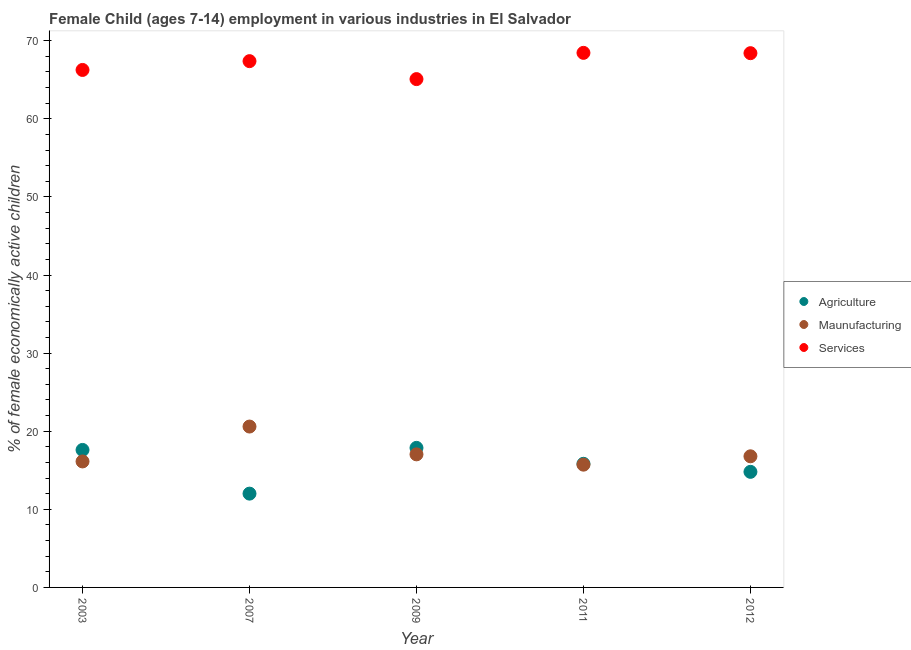Is the number of dotlines equal to the number of legend labels?
Offer a very short reply. Yes. What is the percentage of economically active children in manufacturing in 2009?
Your answer should be very brief. 17.04. Across all years, what is the maximum percentage of economically active children in agriculture?
Offer a terse response. 17.87. Across all years, what is the minimum percentage of economically active children in agriculture?
Provide a short and direct response. 12.01. What is the total percentage of economically active children in services in the graph?
Provide a succinct answer. 335.6. What is the difference between the percentage of economically active children in agriculture in 2003 and that in 2007?
Provide a short and direct response. 5.6. What is the difference between the percentage of economically active children in services in 2012 and the percentage of economically active children in manufacturing in 2009?
Offer a very short reply. 51.37. What is the average percentage of economically active children in agriculture per year?
Provide a succinct answer. 15.62. In the year 2009, what is the difference between the percentage of economically active children in services and percentage of economically active children in manufacturing?
Keep it short and to the point. 48.05. What is the ratio of the percentage of economically active children in manufacturing in 2003 to that in 2007?
Keep it short and to the point. 0.78. Is the difference between the percentage of economically active children in services in 2009 and 2011 greater than the difference between the percentage of economically active children in manufacturing in 2009 and 2011?
Keep it short and to the point. No. What is the difference between the highest and the second highest percentage of economically active children in services?
Provide a short and direct response. 0.04. What is the difference between the highest and the lowest percentage of economically active children in services?
Ensure brevity in your answer.  3.36. Is the sum of the percentage of economically active children in manufacturing in 2009 and 2011 greater than the maximum percentage of economically active children in services across all years?
Make the answer very short. No. Is it the case that in every year, the sum of the percentage of economically active children in agriculture and percentage of economically active children in manufacturing is greater than the percentage of economically active children in services?
Offer a very short reply. No. Is the percentage of economically active children in manufacturing strictly greater than the percentage of economically active children in services over the years?
Provide a succinct answer. No. Are the values on the major ticks of Y-axis written in scientific E-notation?
Your answer should be very brief. No. Does the graph contain grids?
Give a very brief answer. No. Where does the legend appear in the graph?
Make the answer very short. Center right. How are the legend labels stacked?
Your answer should be very brief. Vertical. What is the title of the graph?
Provide a succinct answer. Female Child (ages 7-14) employment in various industries in El Salvador. What is the label or title of the Y-axis?
Offer a terse response. % of female economically active children. What is the % of female economically active children in Agriculture in 2003?
Make the answer very short. 17.61. What is the % of female economically active children in Maunufacturing in 2003?
Give a very brief answer. 16.13. What is the % of female economically active children in Services in 2003?
Provide a succinct answer. 66.26. What is the % of female economically active children of Agriculture in 2007?
Your response must be concise. 12.01. What is the % of female economically active children in Maunufacturing in 2007?
Provide a short and direct response. 20.6. What is the % of female economically active children in Services in 2007?
Keep it short and to the point. 67.39. What is the % of female economically active children of Agriculture in 2009?
Make the answer very short. 17.87. What is the % of female economically active children of Maunufacturing in 2009?
Provide a succinct answer. 17.04. What is the % of female economically active children of Services in 2009?
Offer a very short reply. 65.09. What is the % of female economically active children in Agriculture in 2011?
Ensure brevity in your answer.  15.83. What is the % of female economically active children in Maunufacturing in 2011?
Give a very brief answer. 15.72. What is the % of female economically active children in Services in 2011?
Provide a succinct answer. 68.45. What is the % of female economically active children in Maunufacturing in 2012?
Keep it short and to the point. 16.79. What is the % of female economically active children in Services in 2012?
Offer a terse response. 68.41. Across all years, what is the maximum % of female economically active children in Agriculture?
Give a very brief answer. 17.87. Across all years, what is the maximum % of female economically active children of Maunufacturing?
Your answer should be compact. 20.6. Across all years, what is the maximum % of female economically active children in Services?
Your answer should be compact. 68.45. Across all years, what is the minimum % of female economically active children in Agriculture?
Provide a short and direct response. 12.01. Across all years, what is the minimum % of female economically active children in Maunufacturing?
Provide a short and direct response. 15.72. Across all years, what is the minimum % of female economically active children of Services?
Provide a succinct answer. 65.09. What is the total % of female economically active children of Agriculture in the graph?
Provide a succinct answer. 78.12. What is the total % of female economically active children of Maunufacturing in the graph?
Make the answer very short. 86.28. What is the total % of female economically active children of Services in the graph?
Your answer should be compact. 335.6. What is the difference between the % of female economically active children of Agriculture in 2003 and that in 2007?
Your response must be concise. 5.6. What is the difference between the % of female economically active children of Maunufacturing in 2003 and that in 2007?
Give a very brief answer. -4.47. What is the difference between the % of female economically active children of Services in 2003 and that in 2007?
Offer a very short reply. -1.13. What is the difference between the % of female economically active children in Agriculture in 2003 and that in 2009?
Your answer should be compact. -0.26. What is the difference between the % of female economically active children of Maunufacturing in 2003 and that in 2009?
Keep it short and to the point. -0.91. What is the difference between the % of female economically active children in Services in 2003 and that in 2009?
Offer a very short reply. 1.17. What is the difference between the % of female economically active children in Agriculture in 2003 and that in 2011?
Provide a succinct answer. 1.78. What is the difference between the % of female economically active children of Maunufacturing in 2003 and that in 2011?
Ensure brevity in your answer.  0.41. What is the difference between the % of female economically active children of Services in 2003 and that in 2011?
Offer a very short reply. -2.19. What is the difference between the % of female economically active children of Agriculture in 2003 and that in 2012?
Keep it short and to the point. 2.81. What is the difference between the % of female economically active children in Maunufacturing in 2003 and that in 2012?
Offer a very short reply. -0.66. What is the difference between the % of female economically active children in Services in 2003 and that in 2012?
Your response must be concise. -2.15. What is the difference between the % of female economically active children in Agriculture in 2007 and that in 2009?
Give a very brief answer. -5.86. What is the difference between the % of female economically active children in Maunufacturing in 2007 and that in 2009?
Provide a succinct answer. 3.56. What is the difference between the % of female economically active children of Services in 2007 and that in 2009?
Your answer should be compact. 2.3. What is the difference between the % of female economically active children of Agriculture in 2007 and that in 2011?
Offer a very short reply. -3.82. What is the difference between the % of female economically active children of Maunufacturing in 2007 and that in 2011?
Your response must be concise. 4.88. What is the difference between the % of female economically active children of Services in 2007 and that in 2011?
Offer a very short reply. -1.06. What is the difference between the % of female economically active children in Agriculture in 2007 and that in 2012?
Provide a short and direct response. -2.79. What is the difference between the % of female economically active children in Maunufacturing in 2007 and that in 2012?
Make the answer very short. 3.81. What is the difference between the % of female economically active children of Services in 2007 and that in 2012?
Provide a succinct answer. -1.02. What is the difference between the % of female economically active children in Agriculture in 2009 and that in 2011?
Provide a succinct answer. 2.04. What is the difference between the % of female economically active children of Maunufacturing in 2009 and that in 2011?
Your response must be concise. 1.32. What is the difference between the % of female economically active children in Services in 2009 and that in 2011?
Your answer should be compact. -3.36. What is the difference between the % of female economically active children in Agriculture in 2009 and that in 2012?
Offer a very short reply. 3.07. What is the difference between the % of female economically active children in Services in 2009 and that in 2012?
Your answer should be very brief. -3.32. What is the difference between the % of female economically active children in Agriculture in 2011 and that in 2012?
Keep it short and to the point. 1.03. What is the difference between the % of female economically active children in Maunufacturing in 2011 and that in 2012?
Offer a terse response. -1.07. What is the difference between the % of female economically active children of Agriculture in 2003 and the % of female economically active children of Maunufacturing in 2007?
Provide a short and direct response. -2.99. What is the difference between the % of female economically active children of Agriculture in 2003 and the % of female economically active children of Services in 2007?
Offer a very short reply. -49.78. What is the difference between the % of female economically active children of Maunufacturing in 2003 and the % of female economically active children of Services in 2007?
Your response must be concise. -51.26. What is the difference between the % of female economically active children of Agriculture in 2003 and the % of female economically active children of Maunufacturing in 2009?
Your response must be concise. 0.57. What is the difference between the % of female economically active children of Agriculture in 2003 and the % of female economically active children of Services in 2009?
Make the answer very short. -47.48. What is the difference between the % of female economically active children of Maunufacturing in 2003 and the % of female economically active children of Services in 2009?
Provide a short and direct response. -48.96. What is the difference between the % of female economically active children in Agriculture in 2003 and the % of female economically active children in Maunufacturing in 2011?
Your response must be concise. 1.89. What is the difference between the % of female economically active children in Agriculture in 2003 and the % of female economically active children in Services in 2011?
Offer a very short reply. -50.84. What is the difference between the % of female economically active children in Maunufacturing in 2003 and the % of female economically active children in Services in 2011?
Give a very brief answer. -52.32. What is the difference between the % of female economically active children in Agriculture in 2003 and the % of female economically active children in Maunufacturing in 2012?
Give a very brief answer. 0.82. What is the difference between the % of female economically active children of Agriculture in 2003 and the % of female economically active children of Services in 2012?
Your answer should be very brief. -50.8. What is the difference between the % of female economically active children in Maunufacturing in 2003 and the % of female economically active children in Services in 2012?
Give a very brief answer. -52.28. What is the difference between the % of female economically active children in Agriculture in 2007 and the % of female economically active children in Maunufacturing in 2009?
Give a very brief answer. -5.03. What is the difference between the % of female economically active children in Agriculture in 2007 and the % of female economically active children in Services in 2009?
Your response must be concise. -53.08. What is the difference between the % of female economically active children in Maunufacturing in 2007 and the % of female economically active children in Services in 2009?
Make the answer very short. -44.49. What is the difference between the % of female economically active children in Agriculture in 2007 and the % of female economically active children in Maunufacturing in 2011?
Ensure brevity in your answer.  -3.71. What is the difference between the % of female economically active children of Agriculture in 2007 and the % of female economically active children of Services in 2011?
Offer a very short reply. -56.44. What is the difference between the % of female economically active children in Maunufacturing in 2007 and the % of female economically active children in Services in 2011?
Ensure brevity in your answer.  -47.85. What is the difference between the % of female economically active children in Agriculture in 2007 and the % of female economically active children in Maunufacturing in 2012?
Ensure brevity in your answer.  -4.78. What is the difference between the % of female economically active children of Agriculture in 2007 and the % of female economically active children of Services in 2012?
Keep it short and to the point. -56.4. What is the difference between the % of female economically active children in Maunufacturing in 2007 and the % of female economically active children in Services in 2012?
Provide a succinct answer. -47.81. What is the difference between the % of female economically active children of Agriculture in 2009 and the % of female economically active children of Maunufacturing in 2011?
Provide a succinct answer. 2.15. What is the difference between the % of female economically active children in Agriculture in 2009 and the % of female economically active children in Services in 2011?
Your response must be concise. -50.58. What is the difference between the % of female economically active children of Maunufacturing in 2009 and the % of female economically active children of Services in 2011?
Keep it short and to the point. -51.41. What is the difference between the % of female economically active children in Agriculture in 2009 and the % of female economically active children in Maunufacturing in 2012?
Your answer should be compact. 1.08. What is the difference between the % of female economically active children in Agriculture in 2009 and the % of female economically active children in Services in 2012?
Keep it short and to the point. -50.54. What is the difference between the % of female economically active children of Maunufacturing in 2009 and the % of female economically active children of Services in 2012?
Your answer should be very brief. -51.37. What is the difference between the % of female economically active children of Agriculture in 2011 and the % of female economically active children of Maunufacturing in 2012?
Give a very brief answer. -0.96. What is the difference between the % of female economically active children in Agriculture in 2011 and the % of female economically active children in Services in 2012?
Provide a succinct answer. -52.58. What is the difference between the % of female economically active children of Maunufacturing in 2011 and the % of female economically active children of Services in 2012?
Offer a very short reply. -52.69. What is the average % of female economically active children in Agriculture per year?
Ensure brevity in your answer.  15.62. What is the average % of female economically active children in Maunufacturing per year?
Offer a very short reply. 17.26. What is the average % of female economically active children of Services per year?
Your answer should be very brief. 67.12. In the year 2003, what is the difference between the % of female economically active children of Agriculture and % of female economically active children of Maunufacturing?
Give a very brief answer. 1.47. In the year 2003, what is the difference between the % of female economically active children in Agriculture and % of female economically active children in Services?
Keep it short and to the point. -48.66. In the year 2003, what is the difference between the % of female economically active children in Maunufacturing and % of female economically active children in Services?
Keep it short and to the point. -50.13. In the year 2007, what is the difference between the % of female economically active children of Agriculture and % of female economically active children of Maunufacturing?
Your answer should be compact. -8.59. In the year 2007, what is the difference between the % of female economically active children of Agriculture and % of female economically active children of Services?
Make the answer very short. -55.38. In the year 2007, what is the difference between the % of female economically active children of Maunufacturing and % of female economically active children of Services?
Your answer should be very brief. -46.79. In the year 2009, what is the difference between the % of female economically active children in Agriculture and % of female economically active children in Maunufacturing?
Your response must be concise. 0.83. In the year 2009, what is the difference between the % of female economically active children of Agriculture and % of female economically active children of Services?
Offer a very short reply. -47.22. In the year 2009, what is the difference between the % of female economically active children in Maunufacturing and % of female economically active children in Services?
Ensure brevity in your answer.  -48.05. In the year 2011, what is the difference between the % of female economically active children of Agriculture and % of female economically active children of Maunufacturing?
Keep it short and to the point. 0.11. In the year 2011, what is the difference between the % of female economically active children in Agriculture and % of female economically active children in Services?
Offer a terse response. -52.62. In the year 2011, what is the difference between the % of female economically active children in Maunufacturing and % of female economically active children in Services?
Your answer should be very brief. -52.73. In the year 2012, what is the difference between the % of female economically active children in Agriculture and % of female economically active children in Maunufacturing?
Provide a short and direct response. -1.99. In the year 2012, what is the difference between the % of female economically active children in Agriculture and % of female economically active children in Services?
Your answer should be very brief. -53.61. In the year 2012, what is the difference between the % of female economically active children of Maunufacturing and % of female economically active children of Services?
Offer a very short reply. -51.62. What is the ratio of the % of female economically active children in Agriculture in 2003 to that in 2007?
Ensure brevity in your answer.  1.47. What is the ratio of the % of female economically active children of Maunufacturing in 2003 to that in 2007?
Keep it short and to the point. 0.78. What is the ratio of the % of female economically active children in Services in 2003 to that in 2007?
Make the answer very short. 0.98. What is the ratio of the % of female economically active children of Agriculture in 2003 to that in 2009?
Offer a terse response. 0.99. What is the ratio of the % of female economically active children in Maunufacturing in 2003 to that in 2009?
Ensure brevity in your answer.  0.95. What is the ratio of the % of female economically active children of Agriculture in 2003 to that in 2011?
Offer a terse response. 1.11. What is the ratio of the % of female economically active children of Maunufacturing in 2003 to that in 2011?
Provide a succinct answer. 1.03. What is the ratio of the % of female economically active children in Agriculture in 2003 to that in 2012?
Ensure brevity in your answer.  1.19. What is the ratio of the % of female economically active children in Maunufacturing in 2003 to that in 2012?
Keep it short and to the point. 0.96. What is the ratio of the % of female economically active children in Services in 2003 to that in 2012?
Your response must be concise. 0.97. What is the ratio of the % of female economically active children in Agriculture in 2007 to that in 2009?
Provide a short and direct response. 0.67. What is the ratio of the % of female economically active children of Maunufacturing in 2007 to that in 2009?
Ensure brevity in your answer.  1.21. What is the ratio of the % of female economically active children of Services in 2007 to that in 2009?
Your answer should be very brief. 1.04. What is the ratio of the % of female economically active children of Agriculture in 2007 to that in 2011?
Provide a short and direct response. 0.76. What is the ratio of the % of female economically active children of Maunufacturing in 2007 to that in 2011?
Your answer should be compact. 1.31. What is the ratio of the % of female economically active children in Services in 2007 to that in 2011?
Provide a succinct answer. 0.98. What is the ratio of the % of female economically active children of Agriculture in 2007 to that in 2012?
Provide a succinct answer. 0.81. What is the ratio of the % of female economically active children of Maunufacturing in 2007 to that in 2012?
Your answer should be compact. 1.23. What is the ratio of the % of female economically active children of Services in 2007 to that in 2012?
Your response must be concise. 0.99. What is the ratio of the % of female economically active children in Agriculture in 2009 to that in 2011?
Your answer should be compact. 1.13. What is the ratio of the % of female economically active children in Maunufacturing in 2009 to that in 2011?
Your response must be concise. 1.08. What is the ratio of the % of female economically active children in Services in 2009 to that in 2011?
Ensure brevity in your answer.  0.95. What is the ratio of the % of female economically active children of Agriculture in 2009 to that in 2012?
Offer a very short reply. 1.21. What is the ratio of the % of female economically active children in Maunufacturing in 2009 to that in 2012?
Ensure brevity in your answer.  1.01. What is the ratio of the % of female economically active children of Services in 2009 to that in 2012?
Offer a very short reply. 0.95. What is the ratio of the % of female economically active children in Agriculture in 2011 to that in 2012?
Your answer should be compact. 1.07. What is the ratio of the % of female economically active children of Maunufacturing in 2011 to that in 2012?
Make the answer very short. 0.94. What is the ratio of the % of female economically active children of Services in 2011 to that in 2012?
Provide a short and direct response. 1. What is the difference between the highest and the second highest % of female economically active children of Agriculture?
Your answer should be compact. 0.26. What is the difference between the highest and the second highest % of female economically active children in Maunufacturing?
Your answer should be compact. 3.56. What is the difference between the highest and the second highest % of female economically active children in Services?
Keep it short and to the point. 0.04. What is the difference between the highest and the lowest % of female economically active children in Agriculture?
Your answer should be very brief. 5.86. What is the difference between the highest and the lowest % of female economically active children in Maunufacturing?
Offer a very short reply. 4.88. What is the difference between the highest and the lowest % of female economically active children of Services?
Your answer should be compact. 3.36. 